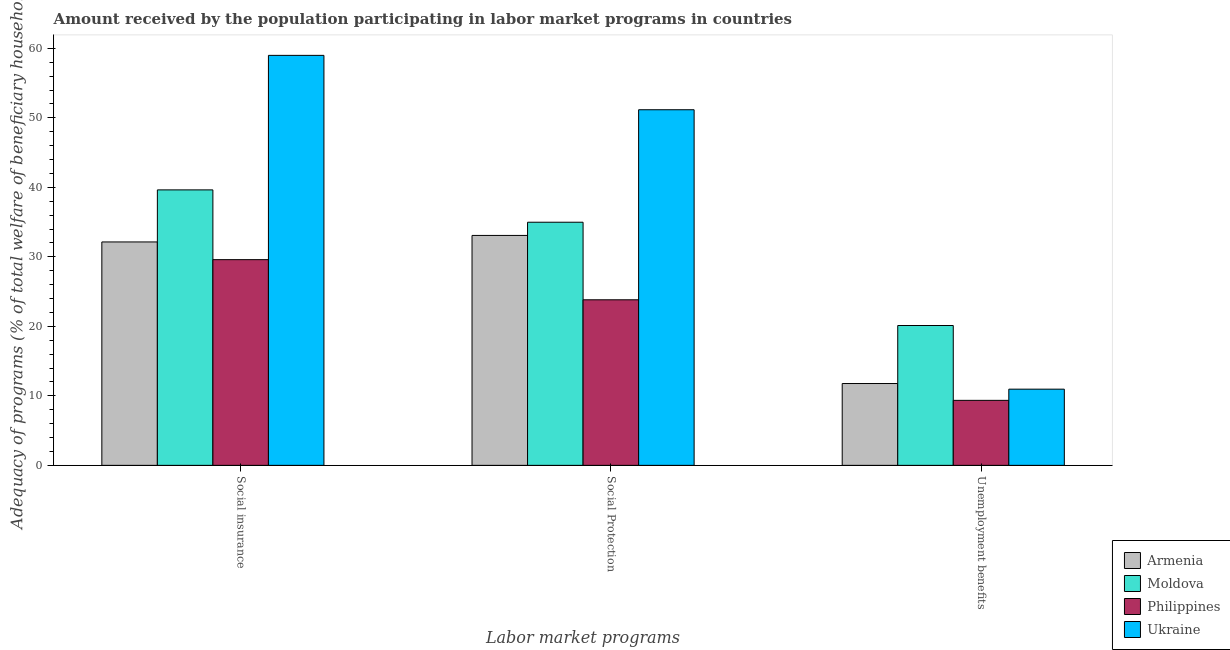Are the number of bars on each tick of the X-axis equal?
Keep it short and to the point. Yes. How many bars are there on the 2nd tick from the left?
Ensure brevity in your answer.  4. How many bars are there on the 1st tick from the right?
Provide a succinct answer. 4. What is the label of the 2nd group of bars from the left?
Your response must be concise. Social Protection. What is the amount received by the population participating in social insurance programs in Moldova?
Offer a terse response. 39.64. Across all countries, what is the maximum amount received by the population participating in social insurance programs?
Make the answer very short. 58.99. Across all countries, what is the minimum amount received by the population participating in unemployment benefits programs?
Your answer should be very brief. 9.35. In which country was the amount received by the population participating in social insurance programs maximum?
Offer a very short reply. Ukraine. What is the total amount received by the population participating in social insurance programs in the graph?
Your response must be concise. 160.38. What is the difference between the amount received by the population participating in social insurance programs in Armenia and that in Ukraine?
Provide a succinct answer. -26.85. What is the difference between the amount received by the population participating in social insurance programs in Ukraine and the amount received by the population participating in social protection programs in Armenia?
Give a very brief answer. 25.91. What is the average amount received by the population participating in unemployment benefits programs per country?
Your answer should be very brief. 13.05. What is the difference between the amount received by the population participating in social protection programs and amount received by the population participating in social insurance programs in Armenia?
Offer a terse response. 0.94. In how many countries, is the amount received by the population participating in social insurance programs greater than 6 %?
Your answer should be very brief. 4. What is the ratio of the amount received by the population participating in unemployment benefits programs in Armenia to that in Moldova?
Ensure brevity in your answer.  0.59. What is the difference between the highest and the second highest amount received by the population participating in social protection programs?
Keep it short and to the point. 16.19. What is the difference between the highest and the lowest amount received by the population participating in unemployment benefits programs?
Provide a succinct answer. 10.77. In how many countries, is the amount received by the population participating in social protection programs greater than the average amount received by the population participating in social protection programs taken over all countries?
Provide a succinct answer. 1. Is the sum of the amount received by the population participating in social insurance programs in Philippines and Armenia greater than the maximum amount received by the population participating in social protection programs across all countries?
Make the answer very short. Yes. What does the 2nd bar from the left in Social insurance represents?
Your answer should be very brief. Moldova. What does the 1st bar from the right in Social insurance represents?
Your answer should be very brief. Ukraine. Is it the case that in every country, the sum of the amount received by the population participating in social insurance programs and amount received by the population participating in social protection programs is greater than the amount received by the population participating in unemployment benefits programs?
Keep it short and to the point. Yes. How many bars are there?
Provide a short and direct response. 12. What is the difference between two consecutive major ticks on the Y-axis?
Keep it short and to the point. 10. Does the graph contain any zero values?
Provide a short and direct response. No. How many legend labels are there?
Your answer should be very brief. 4. What is the title of the graph?
Provide a short and direct response. Amount received by the population participating in labor market programs in countries. Does "Georgia" appear as one of the legend labels in the graph?
Ensure brevity in your answer.  No. What is the label or title of the X-axis?
Give a very brief answer. Labor market programs. What is the label or title of the Y-axis?
Your answer should be compact. Adequacy of programs (% of total welfare of beneficiary households). What is the Adequacy of programs (% of total welfare of beneficiary households) of Armenia in Social insurance?
Provide a succinct answer. 32.15. What is the Adequacy of programs (% of total welfare of beneficiary households) in Moldova in Social insurance?
Give a very brief answer. 39.64. What is the Adequacy of programs (% of total welfare of beneficiary households) in Philippines in Social insurance?
Your response must be concise. 29.6. What is the Adequacy of programs (% of total welfare of beneficiary households) of Ukraine in Social insurance?
Offer a terse response. 58.99. What is the Adequacy of programs (% of total welfare of beneficiary households) in Armenia in Social Protection?
Keep it short and to the point. 33.08. What is the Adequacy of programs (% of total welfare of beneficiary households) in Moldova in Social Protection?
Provide a succinct answer. 34.98. What is the Adequacy of programs (% of total welfare of beneficiary households) of Philippines in Social Protection?
Give a very brief answer. 23.82. What is the Adequacy of programs (% of total welfare of beneficiary households) in Ukraine in Social Protection?
Provide a short and direct response. 51.17. What is the Adequacy of programs (% of total welfare of beneficiary households) in Armenia in Unemployment benefits?
Offer a terse response. 11.77. What is the Adequacy of programs (% of total welfare of beneficiary households) in Moldova in Unemployment benefits?
Your answer should be very brief. 20.12. What is the Adequacy of programs (% of total welfare of beneficiary households) in Philippines in Unemployment benefits?
Keep it short and to the point. 9.35. What is the Adequacy of programs (% of total welfare of beneficiary households) of Ukraine in Unemployment benefits?
Offer a terse response. 10.96. Across all Labor market programs, what is the maximum Adequacy of programs (% of total welfare of beneficiary households) in Armenia?
Your answer should be very brief. 33.08. Across all Labor market programs, what is the maximum Adequacy of programs (% of total welfare of beneficiary households) in Moldova?
Offer a terse response. 39.64. Across all Labor market programs, what is the maximum Adequacy of programs (% of total welfare of beneficiary households) of Philippines?
Your answer should be compact. 29.6. Across all Labor market programs, what is the maximum Adequacy of programs (% of total welfare of beneficiary households) of Ukraine?
Keep it short and to the point. 58.99. Across all Labor market programs, what is the minimum Adequacy of programs (% of total welfare of beneficiary households) of Armenia?
Offer a terse response. 11.77. Across all Labor market programs, what is the minimum Adequacy of programs (% of total welfare of beneficiary households) of Moldova?
Offer a terse response. 20.12. Across all Labor market programs, what is the minimum Adequacy of programs (% of total welfare of beneficiary households) in Philippines?
Ensure brevity in your answer.  9.35. Across all Labor market programs, what is the minimum Adequacy of programs (% of total welfare of beneficiary households) of Ukraine?
Offer a very short reply. 10.96. What is the total Adequacy of programs (% of total welfare of beneficiary households) of Armenia in the graph?
Your answer should be compact. 77.01. What is the total Adequacy of programs (% of total welfare of beneficiary households) in Moldova in the graph?
Make the answer very short. 94.75. What is the total Adequacy of programs (% of total welfare of beneficiary households) of Philippines in the graph?
Your answer should be compact. 62.78. What is the total Adequacy of programs (% of total welfare of beneficiary households) of Ukraine in the graph?
Keep it short and to the point. 121.13. What is the difference between the Adequacy of programs (% of total welfare of beneficiary households) in Armenia in Social insurance and that in Social Protection?
Your answer should be very brief. -0.94. What is the difference between the Adequacy of programs (% of total welfare of beneficiary households) in Moldova in Social insurance and that in Social Protection?
Your response must be concise. 4.65. What is the difference between the Adequacy of programs (% of total welfare of beneficiary households) in Philippines in Social insurance and that in Social Protection?
Your response must be concise. 5.78. What is the difference between the Adequacy of programs (% of total welfare of beneficiary households) of Ukraine in Social insurance and that in Social Protection?
Your response must be concise. 7.82. What is the difference between the Adequacy of programs (% of total welfare of beneficiary households) in Armenia in Social insurance and that in Unemployment benefits?
Your response must be concise. 20.37. What is the difference between the Adequacy of programs (% of total welfare of beneficiary households) in Moldova in Social insurance and that in Unemployment benefits?
Your answer should be very brief. 19.52. What is the difference between the Adequacy of programs (% of total welfare of beneficiary households) in Philippines in Social insurance and that in Unemployment benefits?
Offer a very short reply. 20.25. What is the difference between the Adequacy of programs (% of total welfare of beneficiary households) of Ukraine in Social insurance and that in Unemployment benefits?
Provide a succinct answer. 48.03. What is the difference between the Adequacy of programs (% of total welfare of beneficiary households) of Armenia in Social Protection and that in Unemployment benefits?
Your answer should be compact. 21.31. What is the difference between the Adequacy of programs (% of total welfare of beneficiary households) in Moldova in Social Protection and that in Unemployment benefits?
Provide a short and direct response. 14.86. What is the difference between the Adequacy of programs (% of total welfare of beneficiary households) in Philippines in Social Protection and that in Unemployment benefits?
Provide a succinct answer. 14.47. What is the difference between the Adequacy of programs (% of total welfare of beneficiary households) in Ukraine in Social Protection and that in Unemployment benefits?
Keep it short and to the point. 40.21. What is the difference between the Adequacy of programs (% of total welfare of beneficiary households) in Armenia in Social insurance and the Adequacy of programs (% of total welfare of beneficiary households) in Moldova in Social Protection?
Make the answer very short. -2.84. What is the difference between the Adequacy of programs (% of total welfare of beneficiary households) of Armenia in Social insurance and the Adequacy of programs (% of total welfare of beneficiary households) of Philippines in Social Protection?
Make the answer very short. 8.32. What is the difference between the Adequacy of programs (% of total welfare of beneficiary households) in Armenia in Social insurance and the Adequacy of programs (% of total welfare of beneficiary households) in Ukraine in Social Protection?
Your answer should be compact. -19.02. What is the difference between the Adequacy of programs (% of total welfare of beneficiary households) of Moldova in Social insurance and the Adequacy of programs (% of total welfare of beneficiary households) of Philippines in Social Protection?
Offer a very short reply. 15.81. What is the difference between the Adequacy of programs (% of total welfare of beneficiary households) of Moldova in Social insurance and the Adequacy of programs (% of total welfare of beneficiary households) of Ukraine in Social Protection?
Give a very brief answer. -11.53. What is the difference between the Adequacy of programs (% of total welfare of beneficiary households) of Philippines in Social insurance and the Adequacy of programs (% of total welfare of beneficiary households) of Ukraine in Social Protection?
Give a very brief answer. -21.57. What is the difference between the Adequacy of programs (% of total welfare of beneficiary households) of Armenia in Social insurance and the Adequacy of programs (% of total welfare of beneficiary households) of Moldova in Unemployment benefits?
Give a very brief answer. 12.03. What is the difference between the Adequacy of programs (% of total welfare of beneficiary households) of Armenia in Social insurance and the Adequacy of programs (% of total welfare of beneficiary households) of Philippines in Unemployment benefits?
Keep it short and to the point. 22.79. What is the difference between the Adequacy of programs (% of total welfare of beneficiary households) of Armenia in Social insurance and the Adequacy of programs (% of total welfare of beneficiary households) of Ukraine in Unemployment benefits?
Offer a very short reply. 21.19. What is the difference between the Adequacy of programs (% of total welfare of beneficiary households) of Moldova in Social insurance and the Adequacy of programs (% of total welfare of beneficiary households) of Philippines in Unemployment benefits?
Offer a terse response. 30.28. What is the difference between the Adequacy of programs (% of total welfare of beneficiary households) of Moldova in Social insurance and the Adequacy of programs (% of total welfare of beneficiary households) of Ukraine in Unemployment benefits?
Keep it short and to the point. 28.68. What is the difference between the Adequacy of programs (% of total welfare of beneficiary households) of Philippines in Social insurance and the Adequacy of programs (% of total welfare of beneficiary households) of Ukraine in Unemployment benefits?
Offer a very short reply. 18.64. What is the difference between the Adequacy of programs (% of total welfare of beneficiary households) of Armenia in Social Protection and the Adequacy of programs (% of total welfare of beneficiary households) of Moldova in Unemployment benefits?
Your answer should be compact. 12.96. What is the difference between the Adequacy of programs (% of total welfare of beneficiary households) in Armenia in Social Protection and the Adequacy of programs (% of total welfare of beneficiary households) in Philippines in Unemployment benefits?
Provide a succinct answer. 23.73. What is the difference between the Adequacy of programs (% of total welfare of beneficiary households) of Armenia in Social Protection and the Adequacy of programs (% of total welfare of beneficiary households) of Ukraine in Unemployment benefits?
Give a very brief answer. 22.12. What is the difference between the Adequacy of programs (% of total welfare of beneficiary households) in Moldova in Social Protection and the Adequacy of programs (% of total welfare of beneficiary households) in Philippines in Unemployment benefits?
Provide a succinct answer. 25.63. What is the difference between the Adequacy of programs (% of total welfare of beneficiary households) in Moldova in Social Protection and the Adequacy of programs (% of total welfare of beneficiary households) in Ukraine in Unemployment benefits?
Ensure brevity in your answer.  24.02. What is the difference between the Adequacy of programs (% of total welfare of beneficiary households) in Philippines in Social Protection and the Adequacy of programs (% of total welfare of beneficiary households) in Ukraine in Unemployment benefits?
Provide a succinct answer. 12.86. What is the average Adequacy of programs (% of total welfare of beneficiary households) of Armenia per Labor market programs?
Your response must be concise. 25.67. What is the average Adequacy of programs (% of total welfare of beneficiary households) of Moldova per Labor market programs?
Give a very brief answer. 31.58. What is the average Adequacy of programs (% of total welfare of beneficiary households) in Philippines per Labor market programs?
Offer a terse response. 20.93. What is the average Adequacy of programs (% of total welfare of beneficiary households) of Ukraine per Labor market programs?
Your answer should be compact. 40.38. What is the difference between the Adequacy of programs (% of total welfare of beneficiary households) in Armenia and Adequacy of programs (% of total welfare of beneficiary households) in Moldova in Social insurance?
Keep it short and to the point. -7.49. What is the difference between the Adequacy of programs (% of total welfare of beneficiary households) in Armenia and Adequacy of programs (% of total welfare of beneficiary households) in Philippines in Social insurance?
Offer a very short reply. 2.55. What is the difference between the Adequacy of programs (% of total welfare of beneficiary households) of Armenia and Adequacy of programs (% of total welfare of beneficiary households) of Ukraine in Social insurance?
Offer a very short reply. -26.85. What is the difference between the Adequacy of programs (% of total welfare of beneficiary households) of Moldova and Adequacy of programs (% of total welfare of beneficiary households) of Philippines in Social insurance?
Your response must be concise. 10.04. What is the difference between the Adequacy of programs (% of total welfare of beneficiary households) of Moldova and Adequacy of programs (% of total welfare of beneficiary households) of Ukraine in Social insurance?
Your answer should be compact. -19.36. What is the difference between the Adequacy of programs (% of total welfare of beneficiary households) in Philippines and Adequacy of programs (% of total welfare of beneficiary households) in Ukraine in Social insurance?
Your answer should be compact. -29.4. What is the difference between the Adequacy of programs (% of total welfare of beneficiary households) in Armenia and Adequacy of programs (% of total welfare of beneficiary households) in Moldova in Social Protection?
Make the answer very short. -1.9. What is the difference between the Adequacy of programs (% of total welfare of beneficiary households) in Armenia and Adequacy of programs (% of total welfare of beneficiary households) in Philippines in Social Protection?
Your response must be concise. 9.26. What is the difference between the Adequacy of programs (% of total welfare of beneficiary households) in Armenia and Adequacy of programs (% of total welfare of beneficiary households) in Ukraine in Social Protection?
Provide a succinct answer. -18.09. What is the difference between the Adequacy of programs (% of total welfare of beneficiary households) of Moldova and Adequacy of programs (% of total welfare of beneficiary households) of Philippines in Social Protection?
Make the answer very short. 11.16. What is the difference between the Adequacy of programs (% of total welfare of beneficiary households) of Moldova and Adequacy of programs (% of total welfare of beneficiary households) of Ukraine in Social Protection?
Offer a terse response. -16.19. What is the difference between the Adequacy of programs (% of total welfare of beneficiary households) in Philippines and Adequacy of programs (% of total welfare of beneficiary households) in Ukraine in Social Protection?
Keep it short and to the point. -27.35. What is the difference between the Adequacy of programs (% of total welfare of beneficiary households) of Armenia and Adequacy of programs (% of total welfare of beneficiary households) of Moldova in Unemployment benefits?
Ensure brevity in your answer.  -8.35. What is the difference between the Adequacy of programs (% of total welfare of beneficiary households) in Armenia and Adequacy of programs (% of total welfare of beneficiary households) in Philippines in Unemployment benefits?
Offer a very short reply. 2.42. What is the difference between the Adequacy of programs (% of total welfare of beneficiary households) of Armenia and Adequacy of programs (% of total welfare of beneficiary households) of Ukraine in Unemployment benefits?
Provide a short and direct response. 0.81. What is the difference between the Adequacy of programs (% of total welfare of beneficiary households) in Moldova and Adequacy of programs (% of total welfare of beneficiary households) in Philippines in Unemployment benefits?
Make the answer very short. 10.77. What is the difference between the Adequacy of programs (% of total welfare of beneficiary households) of Moldova and Adequacy of programs (% of total welfare of beneficiary households) of Ukraine in Unemployment benefits?
Keep it short and to the point. 9.16. What is the difference between the Adequacy of programs (% of total welfare of beneficiary households) in Philippines and Adequacy of programs (% of total welfare of beneficiary households) in Ukraine in Unemployment benefits?
Keep it short and to the point. -1.61. What is the ratio of the Adequacy of programs (% of total welfare of beneficiary households) of Armenia in Social insurance to that in Social Protection?
Give a very brief answer. 0.97. What is the ratio of the Adequacy of programs (% of total welfare of beneficiary households) in Moldova in Social insurance to that in Social Protection?
Offer a terse response. 1.13. What is the ratio of the Adequacy of programs (% of total welfare of beneficiary households) of Philippines in Social insurance to that in Social Protection?
Offer a terse response. 1.24. What is the ratio of the Adequacy of programs (% of total welfare of beneficiary households) of Ukraine in Social insurance to that in Social Protection?
Provide a short and direct response. 1.15. What is the ratio of the Adequacy of programs (% of total welfare of beneficiary households) in Armenia in Social insurance to that in Unemployment benefits?
Your response must be concise. 2.73. What is the ratio of the Adequacy of programs (% of total welfare of beneficiary households) in Moldova in Social insurance to that in Unemployment benefits?
Make the answer very short. 1.97. What is the ratio of the Adequacy of programs (% of total welfare of beneficiary households) of Philippines in Social insurance to that in Unemployment benefits?
Provide a succinct answer. 3.16. What is the ratio of the Adequacy of programs (% of total welfare of beneficiary households) in Ukraine in Social insurance to that in Unemployment benefits?
Offer a very short reply. 5.38. What is the ratio of the Adequacy of programs (% of total welfare of beneficiary households) of Armenia in Social Protection to that in Unemployment benefits?
Your response must be concise. 2.81. What is the ratio of the Adequacy of programs (% of total welfare of beneficiary households) of Moldova in Social Protection to that in Unemployment benefits?
Ensure brevity in your answer.  1.74. What is the ratio of the Adequacy of programs (% of total welfare of beneficiary households) in Philippines in Social Protection to that in Unemployment benefits?
Your answer should be compact. 2.55. What is the ratio of the Adequacy of programs (% of total welfare of beneficiary households) of Ukraine in Social Protection to that in Unemployment benefits?
Keep it short and to the point. 4.67. What is the difference between the highest and the second highest Adequacy of programs (% of total welfare of beneficiary households) in Armenia?
Make the answer very short. 0.94. What is the difference between the highest and the second highest Adequacy of programs (% of total welfare of beneficiary households) in Moldova?
Offer a terse response. 4.65. What is the difference between the highest and the second highest Adequacy of programs (% of total welfare of beneficiary households) in Philippines?
Keep it short and to the point. 5.78. What is the difference between the highest and the second highest Adequacy of programs (% of total welfare of beneficiary households) in Ukraine?
Offer a terse response. 7.82. What is the difference between the highest and the lowest Adequacy of programs (% of total welfare of beneficiary households) in Armenia?
Provide a succinct answer. 21.31. What is the difference between the highest and the lowest Adequacy of programs (% of total welfare of beneficiary households) in Moldova?
Your response must be concise. 19.52. What is the difference between the highest and the lowest Adequacy of programs (% of total welfare of beneficiary households) in Philippines?
Give a very brief answer. 20.25. What is the difference between the highest and the lowest Adequacy of programs (% of total welfare of beneficiary households) of Ukraine?
Make the answer very short. 48.03. 